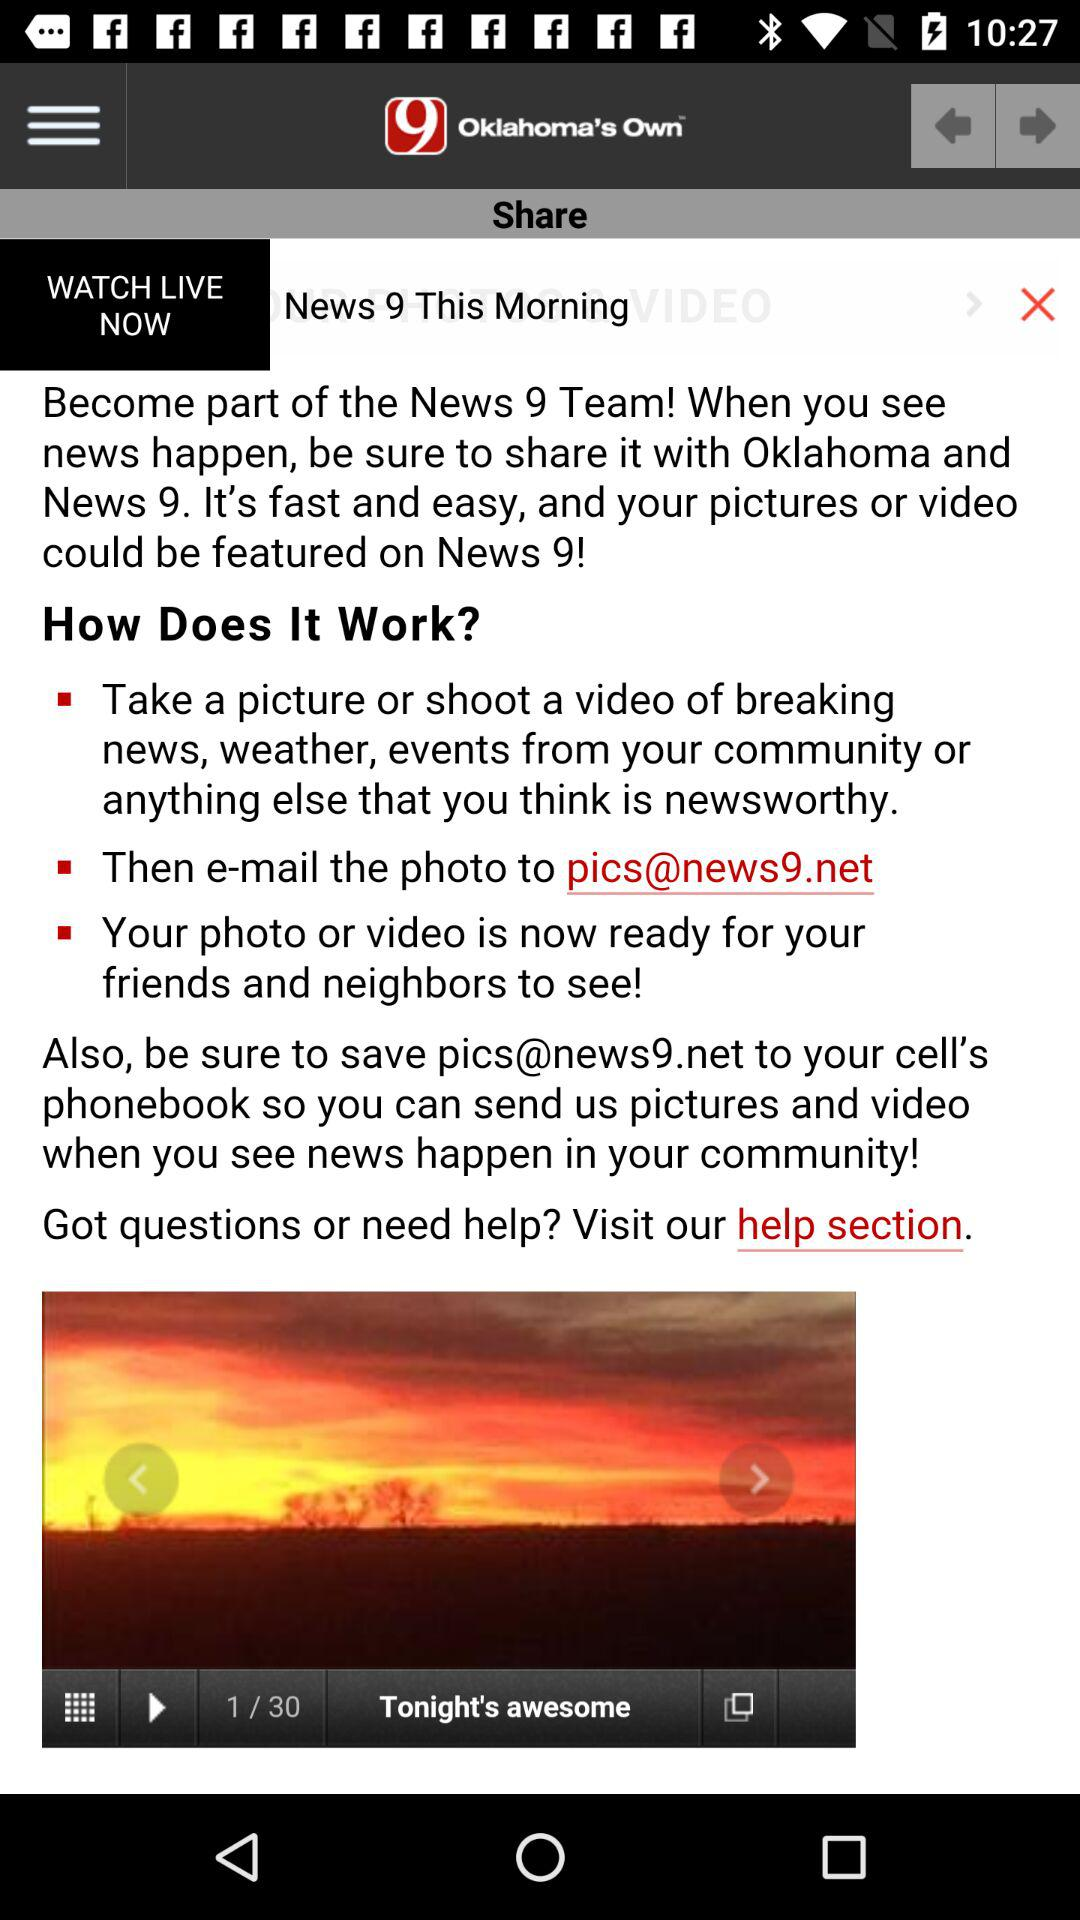What is the news channel name? The channel name is "News 9". 